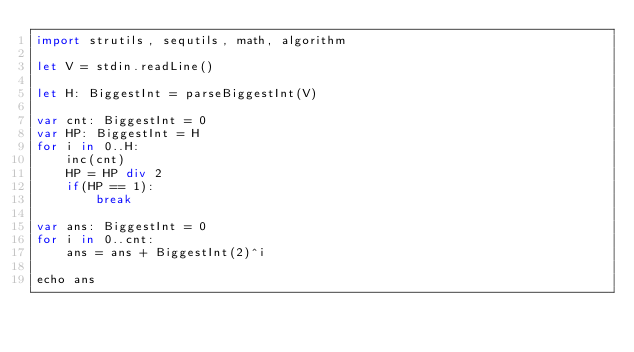<code> <loc_0><loc_0><loc_500><loc_500><_Nim_>import strutils, sequtils, math, algorithm

let V = stdin.readLine()

let H: BiggestInt = parseBiggestInt(V)

var cnt: BiggestInt = 0
var HP: BiggestInt = H
for i in 0..H:
    inc(cnt)
    HP = HP div 2
    if(HP == 1):
        break

var ans: BiggestInt = 0
for i in 0..cnt:
    ans = ans + BiggestInt(2)^i

echo ans
</code> 